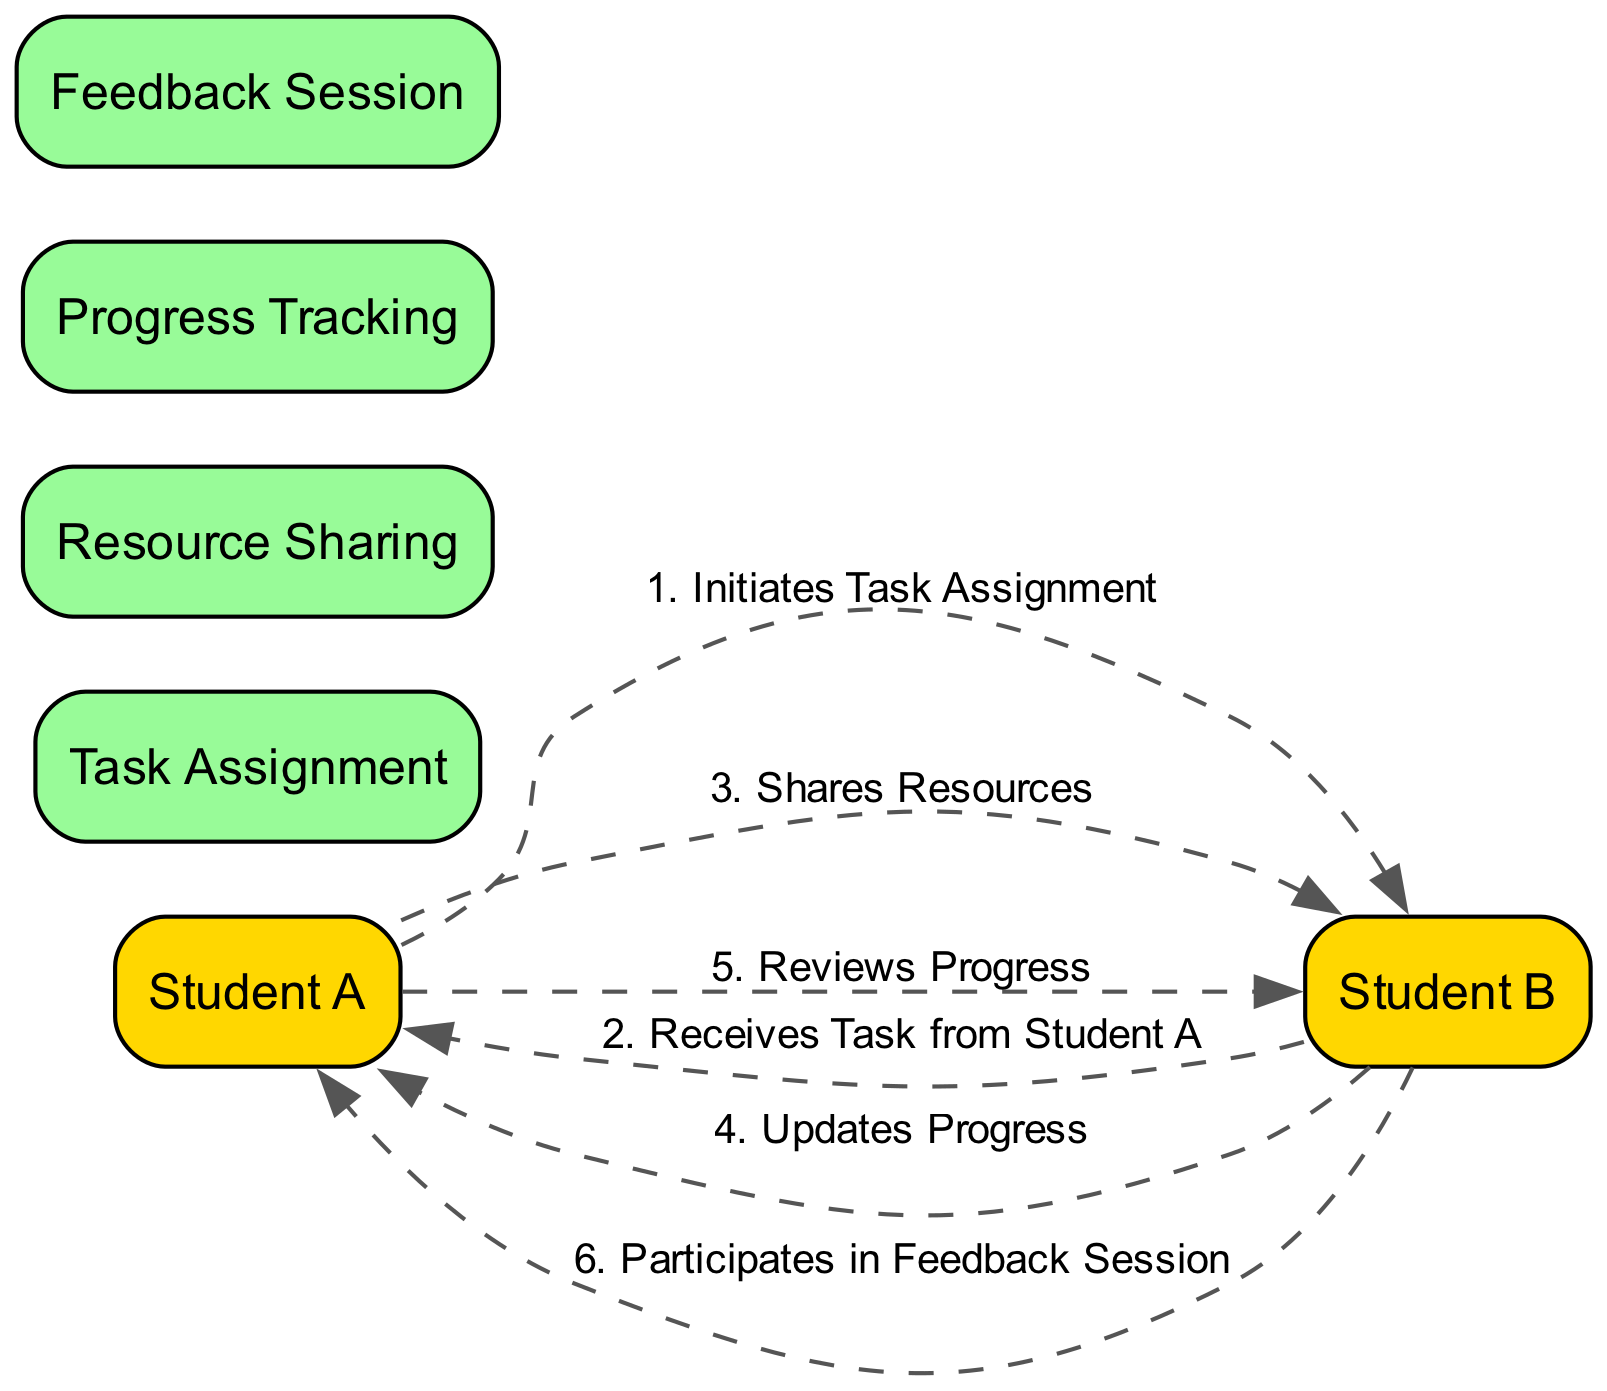What is the first action in the workflow? The first action in the workflow is initiated by Student A, who takes the step to assign a task. This is mentioned as "Initiates Task Assignment" in the workflow sequence.
Answer: Initiates Task Assignment Which student receives the task? Student B receives the task assigned by Student A. This information is clearly stated in the workflow action "Receives Task from Student A."
Answer: Student B How many processes are represented in the diagram? There are four distinct processes represented in the diagram: Task Assignment, Resource Sharing, Progress Tracking, and Feedback Session. This can be counted from the 'processes' list derived from the diagram elements.
Answer: Four What action does Student A take after sharing resources? After sharing resources with Student B, the next action taken by Student A is to review progress. This is indicated in the sequence of workflow actions.
Answer: Reviews Progress Which student participates in the feedback session? Student B participates in the feedback session. This can be found in the workflow step that states "Participates in Feedback Session."
Answer: Student B What type of relationship connects the "Initiates Task Assignment" to "Receives Task from Student A"? The relationship connecting "Initiates Task Assignment" performed by Student A to "Receives Task from Student A" performed by Student B is a dashed line, indicating a communication flow between the two students.
Answer: Dashed line In total, how many actions are listed in the workflow? There are six actions listed in the workflow. Each of the steps corresponds to an action taken by either Student A or Student B.
Answer: Six What happens after Student B updates their progress? After updating progress, Student A will review that progress. This indicates the flow of interaction where Student B's task update leads to Student A's review in the workflow.
Answer: Reviews Progress 